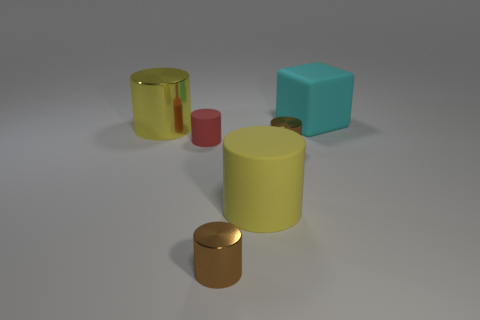Subtract all red cylinders. How many cylinders are left? 4 Subtract all red matte cylinders. How many cylinders are left? 4 Subtract all blue cylinders. Subtract all yellow balls. How many cylinders are left? 5 Add 2 red matte things. How many objects exist? 8 Subtract all blocks. How many objects are left? 5 Add 4 yellow things. How many yellow things are left? 6 Add 1 shiny cylinders. How many shiny cylinders exist? 4 Subtract 0 yellow balls. How many objects are left? 6 Subtract all cylinders. Subtract all tiny cyan objects. How many objects are left? 1 